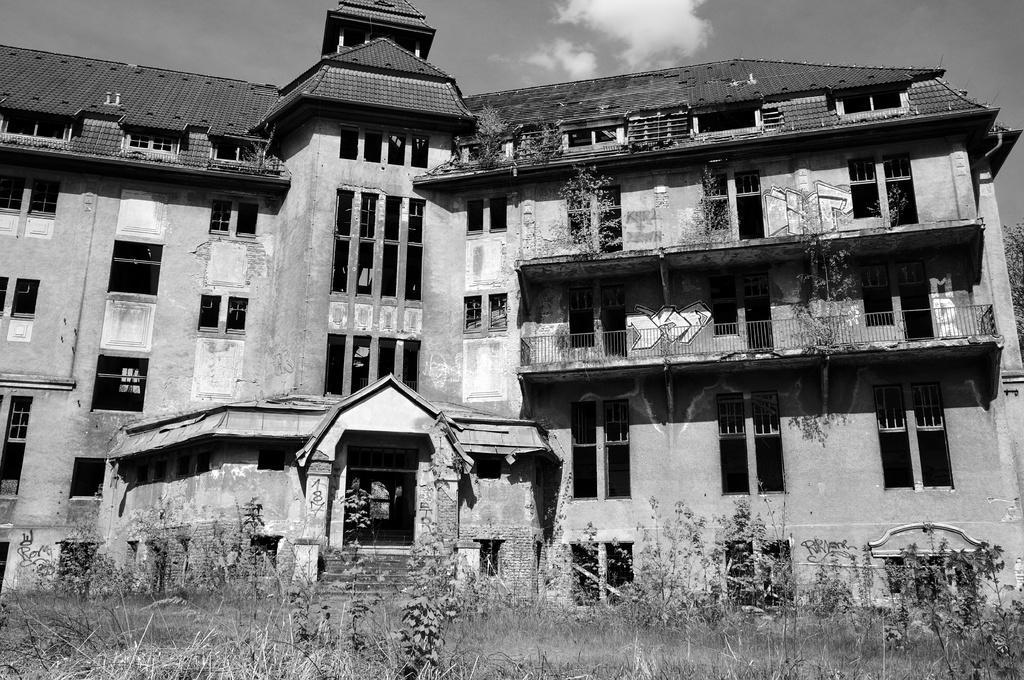Can you describe this image briefly? In this picture there is a building. In the foreground there is a staircase and there is grass and there are plants. At the top there is sky and there are clouds. 